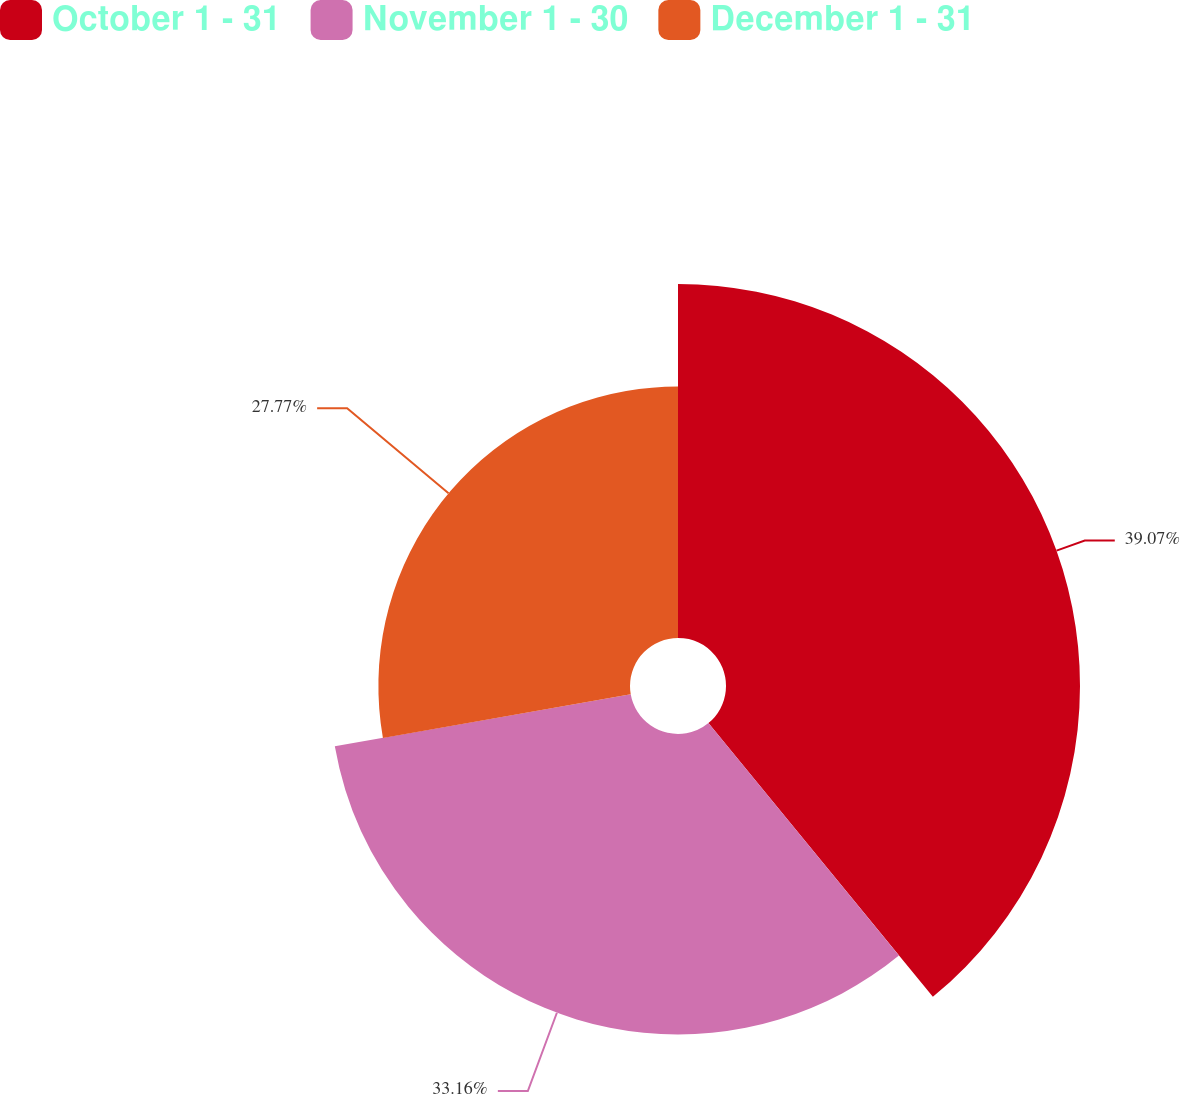<chart> <loc_0><loc_0><loc_500><loc_500><pie_chart><fcel>October 1 - 31<fcel>November 1 - 30<fcel>December 1 - 31<nl><fcel>39.07%<fcel>33.16%<fcel>27.77%<nl></chart> 